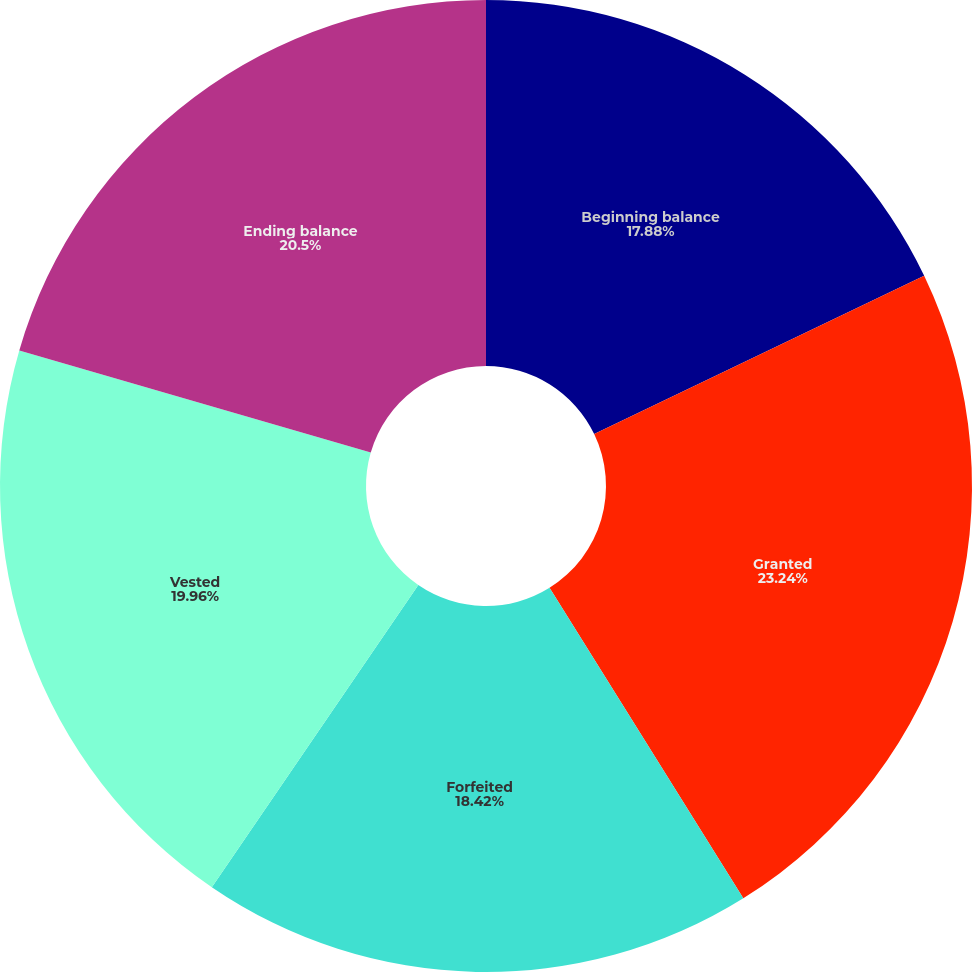Convert chart. <chart><loc_0><loc_0><loc_500><loc_500><pie_chart><fcel>Beginning balance<fcel>Granted<fcel>Forfeited<fcel>Vested<fcel>Ending balance<nl><fcel>17.88%<fcel>23.24%<fcel>18.42%<fcel>19.96%<fcel>20.5%<nl></chart> 